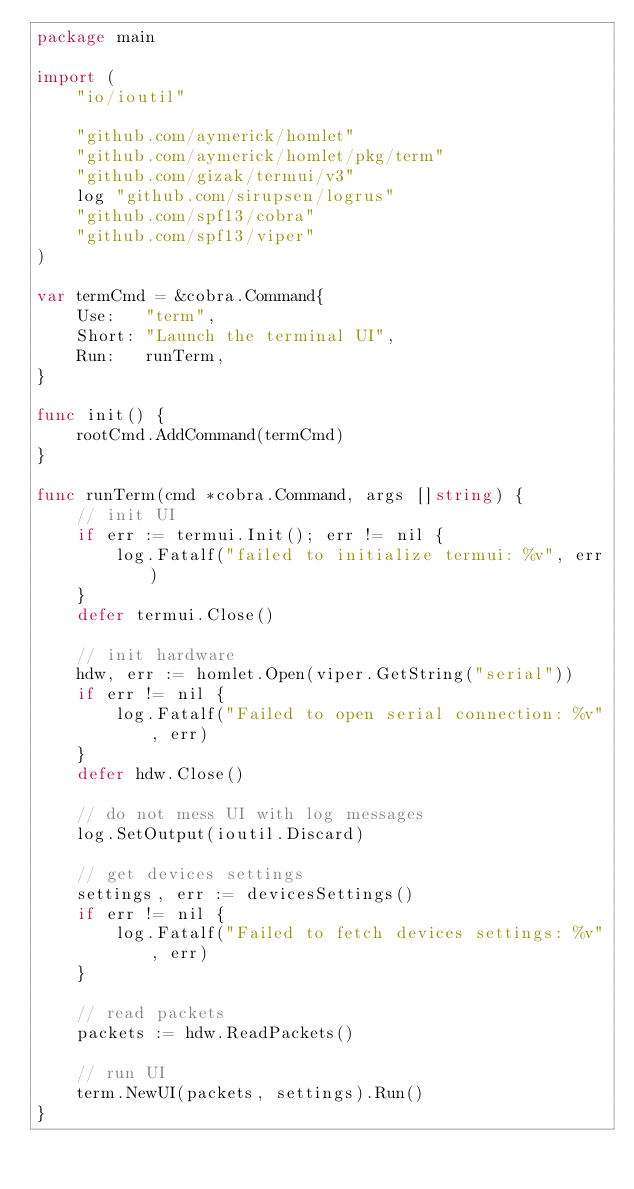Convert code to text. <code><loc_0><loc_0><loc_500><loc_500><_Go_>package main

import (
	"io/ioutil"

	"github.com/aymerick/homlet"
	"github.com/aymerick/homlet/pkg/term"
	"github.com/gizak/termui/v3"
	log "github.com/sirupsen/logrus"
	"github.com/spf13/cobra"
	"github.com/spf13/viper"
)

var termCmd = &cobra.Command{
	Use:   "term",
	Short: "Launch the terminal UI",
	Run:   runTerm,
}

func init() {
	rootCmd.AddCommand(termCmd)
}

func runTerm(cmd *cobra.Command, args []string) {
	// init UI
	if err := termui.Init(); err != nil {
		log.Fatalf("failed to initialize termui: %v", err)
	}
	defer termui.Close()

	// init hardware
	hdw, err := homlet.Open(viper.GetString("serial"))
	if err != nil {
		log.Fatalf("Failed to open serial connection: %v", err)
	}
	defer hdw.Close()

	// do not mess UI with log messages
	log.SetOutput(ioutil.Discard)

	// get devices settings
	settings, err := devicesSettings()
	if err != nil {
		log.Fatalf("Failed to fetch devices settings: %v", err)
	}

	// read packets
	packets := hdw.ReadPackets()

	// run UI
	term.NewUI(packets, settings).Run()
}
</code> 